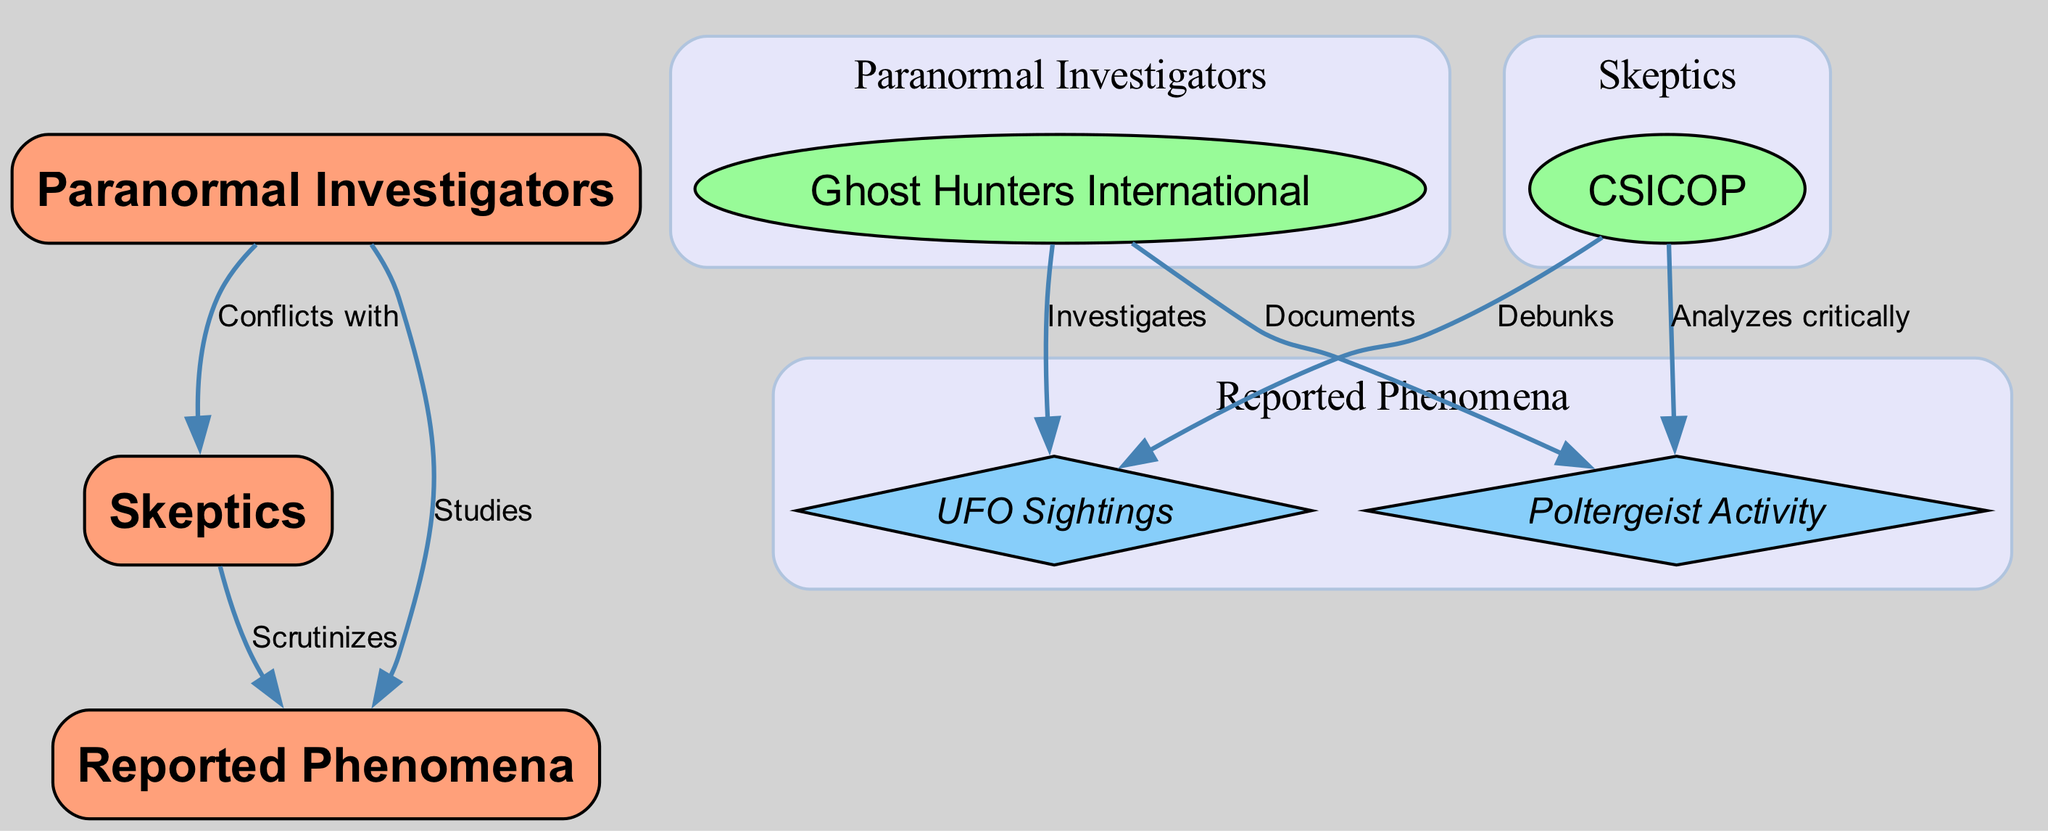What is the total number of nodes in the diagram? To find the total number of nodes, we need to count all the entries in the "nodes" section of the data. There are 7 nodes in total, including groups, subgroups, and phenomena.
Answer: 7 Which subgroup is associated with paranormal investigators? The only subgroup listed under paranormal investigators is "Ghost Hunters International," which is directly linked as a subgroup of the 'Paranormal Investigators' group.
Answer: Ghost Hunters International What phenomena do the paranormal investigators study? According to the edges from the 'Paranormal Investigators' group, they study both 'UFO Sightings' and 'Poltergeist Activity,' as indicated by their relationships to the reported phenomena in the diagram.
Answer: UFO Sightings and Poltergeist Activity How many edges are connected to skeptics? By counting the edges that originate from the 'Skeptics' subgroup in the diagram, we see that there are 2 edges connecting skeptics to reported phenomena (one debunks UFO sightings and the other analyzes poltergeist activity).
Answer: 2 What relationship does the 'Ghost Hunters International' have with 'UFO Sightings'? The edge between 'Ghost Hunters International' and 'UFO Sightings' indicates that they investigate UFO sightings, which shows the direct relationship where one actively engages with the phenomenon.
Answer: Investigates Do skeptics study or scrutinize the reported phenomena? Yes, the skeptics scrutinize the reported phenomena according to the diagram's edges. There is a direct edge from 'Skeptics' to 'Reported Phenomena' labeled 'Scrutinizes,' indicating this relationship.
Answer: Scrutinizes Which group conflicts with the skeptics? The edge from the 'Paranormal Investigators' group to the 'Skeptics' group indicates a conflict between the two groups, showcasing their opposing views regarding paranormal investigations.
Answer: Paranormal Investigators What action is taken by skeptics concerning poltergeist activity? The relationship between the 'Skeptics' subgroup and 'Poltergeist Activity' indicates that they analyze this phenomenon critically. This reflects their approach towards assessing such reports.
Answer: Analyzes critically 